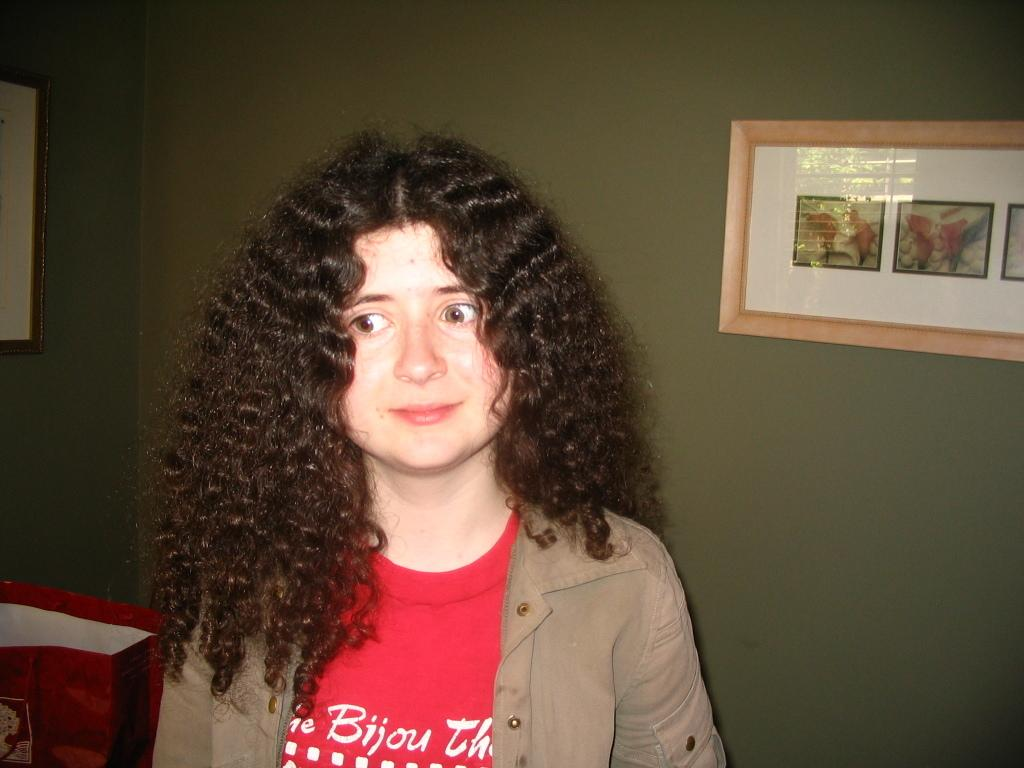Who is the main subject in the image? There is a lady in the center of the image. What can be seen in the background of the image? There is a wall with photo frames in the background of the image. What color is the object to the left side of the image? There is a red color cover to the left side of the image. Are there any giants visible in the image? No, there are no giants present in the image. What type of harmony is being played in the background of the image? There is no music or harmony present in the image; it is a still photograph. 